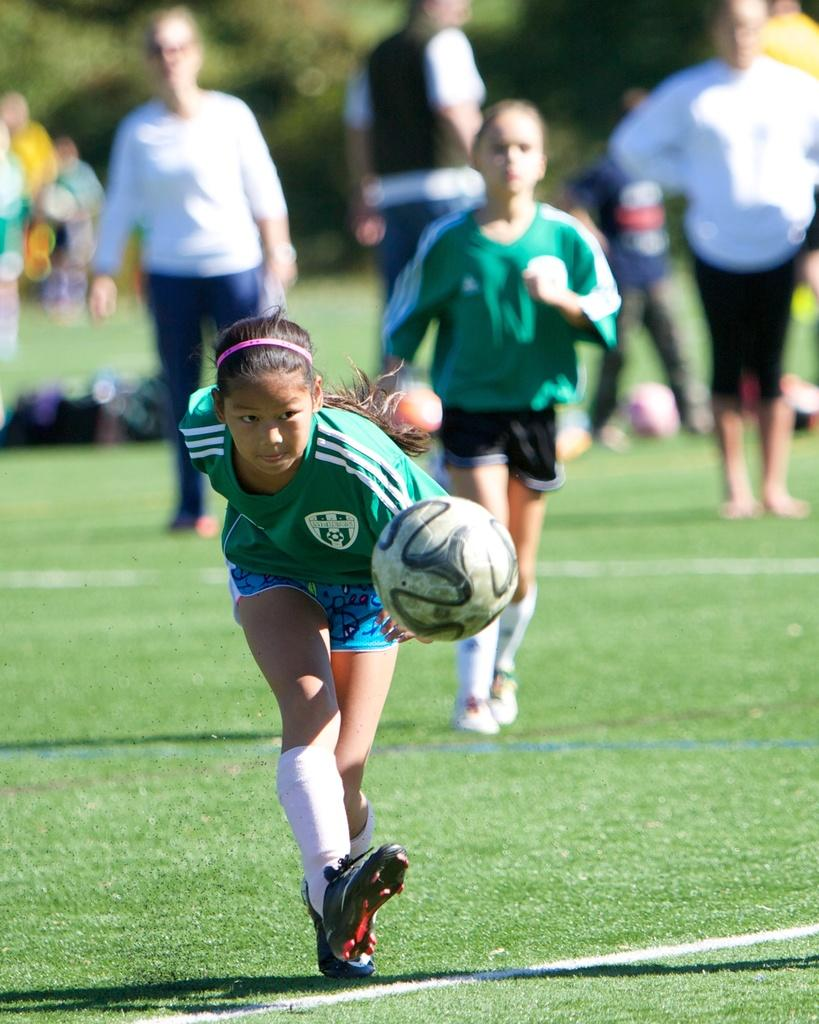How many people are in the image? There are two girls in the image. What activity are the girls engaged in? The girls are playing football. Can you describe the background of the image? There are people standing in the background of the image. What type of carriage can be seen in the image? There is no carriage present in the image. What is the girls using to open the bottle of cork in the image? There is no bottle or cork present in the image. 